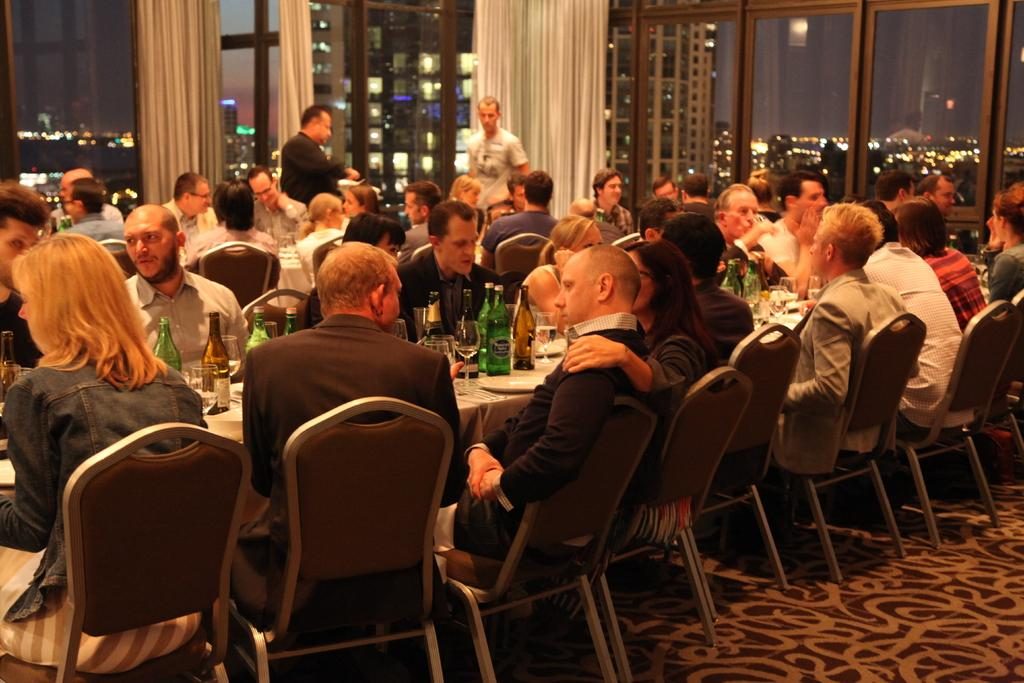How many people are in the image? There are many people in the image. What are the people doing in the image? The people are sitting on chairs in the image. How are the chairs arranged in the image? The chairs are arranged around a table in the image. What can be seen on the table in the image? There are wine bottles on the table in the image. What type of setting is depicted in the image? The setting appears to be a bar area in the image. What architectural feature is present on either side of the room in the image? There are glass windows on either side of the room in the image. How many rabbits are hopping around on the table in the image? There are no rabbits present in the image; only people, chairs, and wine bottles are visible on the table. 